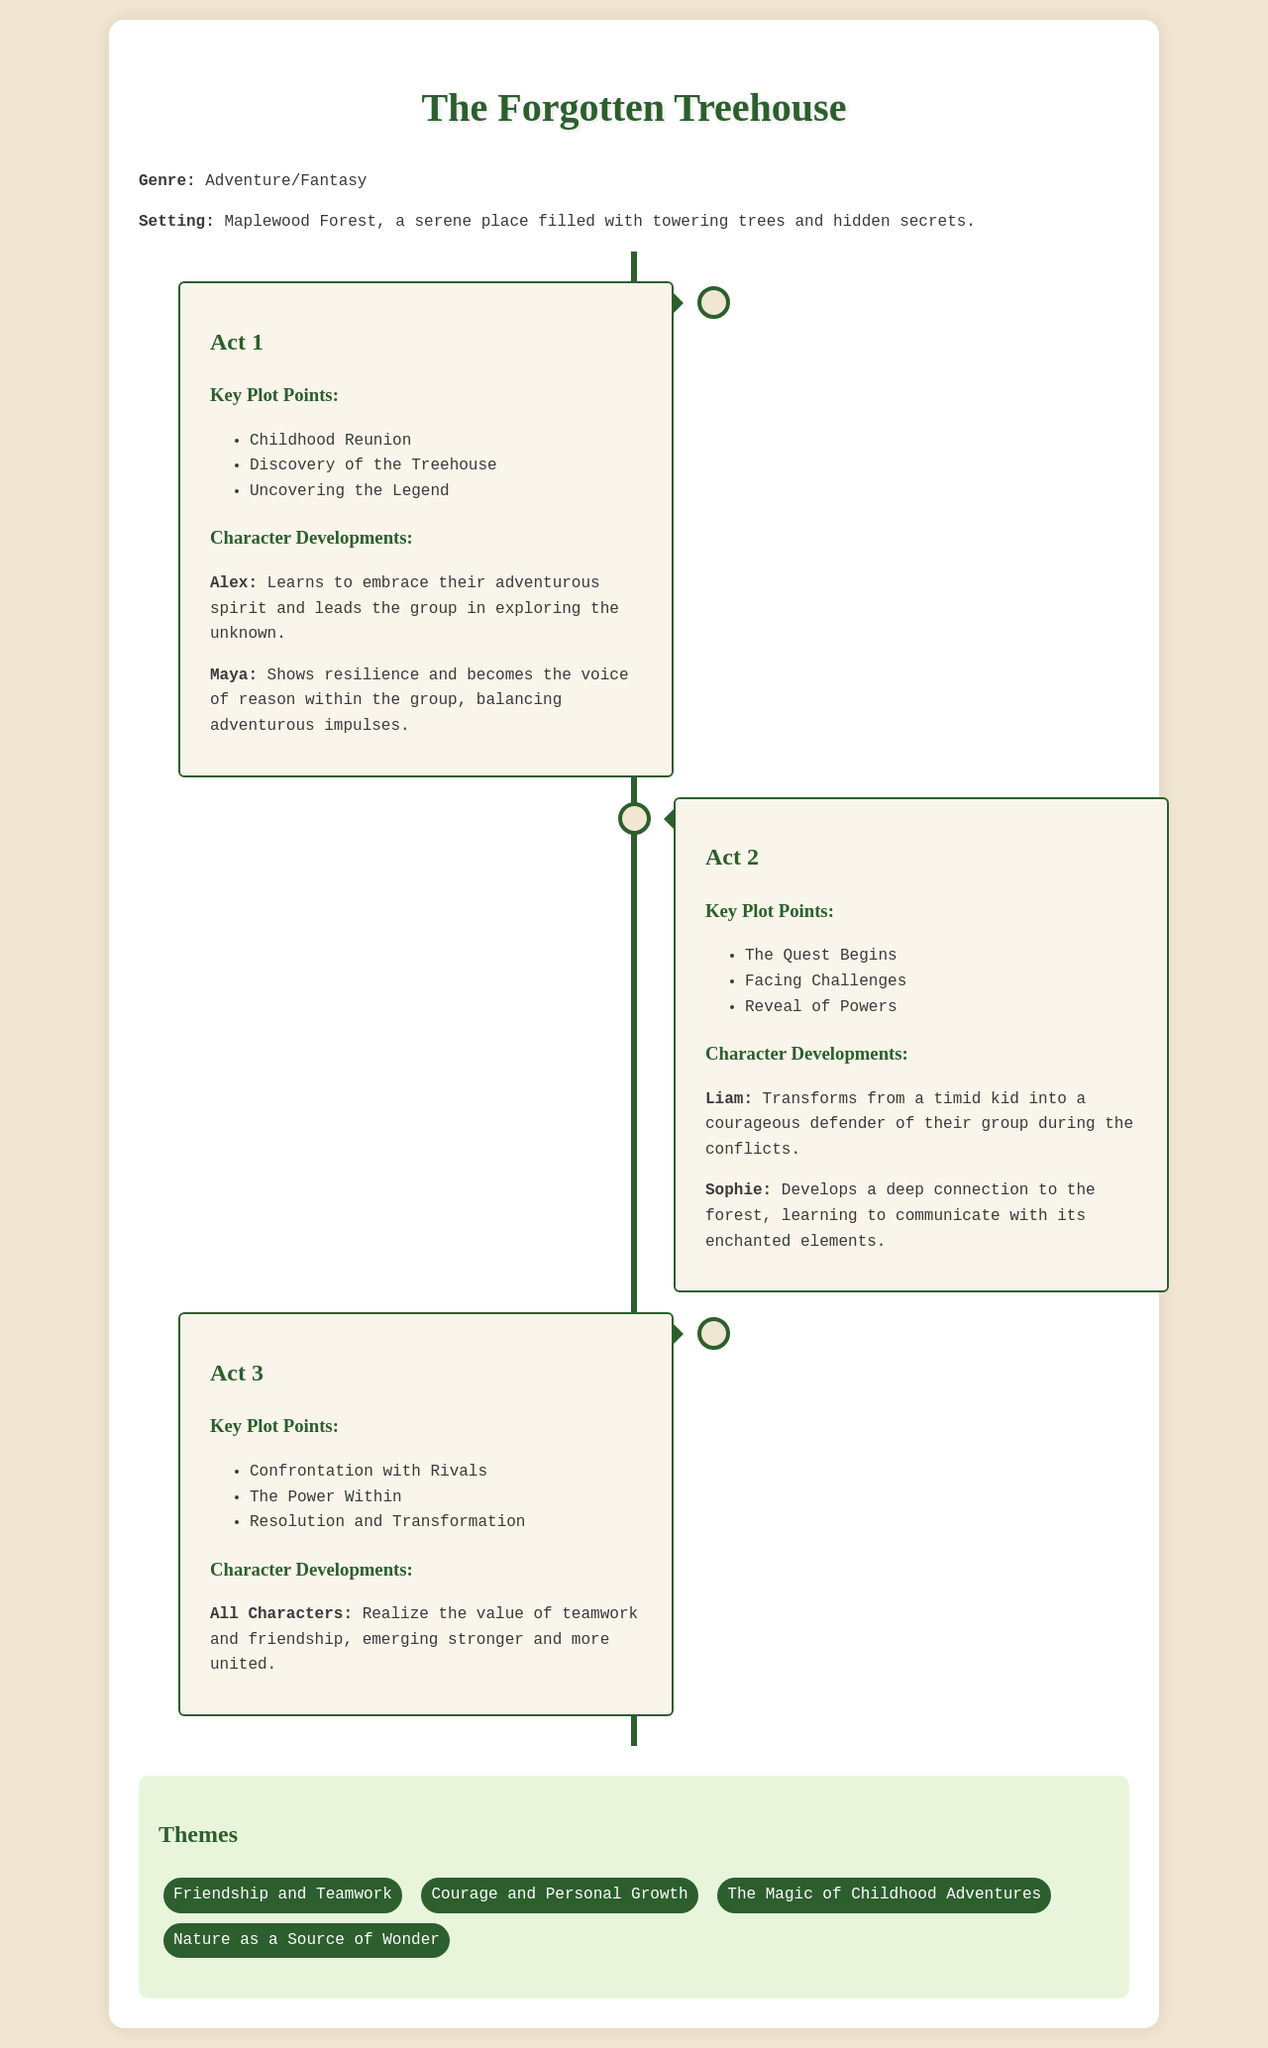What is the title of the story? The title is found at the top of the document.
Answer: The Forgotten Treehouse Who is the main character leading the group? The document specifies Alex's role in character development.
Answer: Alex What forest serves as the story's setting? The setting is mentioned in the introduction of the document.
Answer: Maplewood Forest What key plot point occurs first in Act 1? The key plot points in Act 1 are listed, highlighting the first event.
Answer: Childhood Reunion What transformation does Liam undergo in Act 2? The document describes Liam's character development specifically.
Answer: Courageous defender How many themes are listed in the document? The themes section counts the total themes provided.
Answer: Four What does the group realize at the end of Act 3? The collective realization of all characters is highlighted in the character developments section.
Answer: Value of teamwork and friendship What type of adventure does the story represent? The genre is indicated in the document's initial description.
Answer: Adventure/Fantasy Which character becomes the voice of reason? The character development section in Act 1 points out this trait.
Answer: Maya 